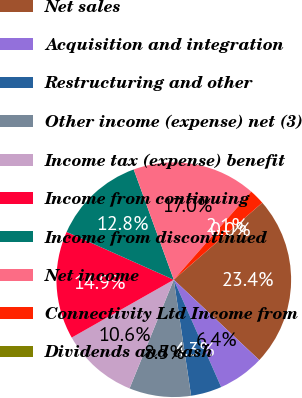Convert chart to OTSL. <chart><loc_0><loc_0><loc_500><loc_500><pie_chart><fcel>Net sales<fcel>Acquisition and integration<fcel>Restructuring and other<fcel>Other income (expense) net (3)<fcel>Income tax (expense) benefit<fcel>Income from continuing<fcel>Income from discontinued<fcel>Net income<fcel>Connectivity Ltd Income from<fcel>Dividends and cash<nl><fcel>23.4%<fcel>6.38%<fcel>4.26%<fcel>8.51%<fcel>10.64%<fcel>14.89%<fcel>12.77%<fcel>17.02%<fcel>2.13%<fcel>0.0%<nl></chart> 